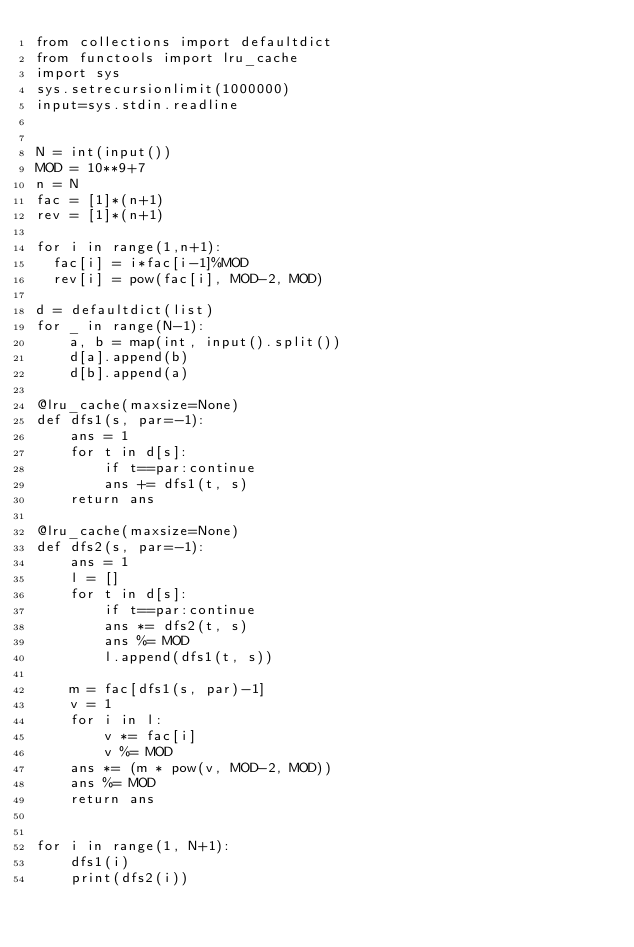Convert code to text. <code><loc_0><loc_0><loc_500><loc_500><_Python_>from collections import defaultdict
from functools import lru_cache
import sys
sys.setrecursionlimit(1000000)
input=sys.stdin.readline


N = int(input())
MOD = 10**9+7
n = N
fac = [1]*(n+1)
rev = [1]*(n+1)
 
for i in range(1,n+1):
  fac[i] = i*fac[i-1]%MOD
  rev[i] = pow(fac[i], MOD-2, MOD)

d = defaultdict(list)
for _ in range(N-1):
    a, b = map(int, input().split())
    d[a].append(b)
    d[b].append(a)

@lru_cache(maxsize=None)
def dfs1(s, par=-1):
    ans = 1
    for t in d[s]:
        if t==par:continue
        ans += dfs1(t, s)
    return ans

@lru_cache(maxsize=None)
def dfs2(s, par=-1):
    ans = 1
    l = []
    for t in d[s]:
        if t==par:continue
        ans *= dfs2(t, s)
        ans %= MOD
        l.append(dfs1(t, s))
    
    m = fac[dfs1(s, par)-1]
    v = 1
    for i in l:
        v *= fac[i]
        v %= MOD
    ans *= (m * pow(v, MOD-2, MOD))
    ans %= MOD
    return ans


for i in range(1, N+1):
    dfs1(i)
    print(dfs2(i))
</code> 